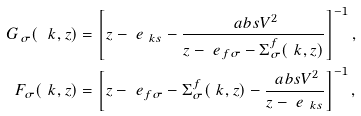Convert formula to latex. <formula><loc_0><loc_0><loc_500><loc_500>G _ { \sigma } ( \ k , z ) & = \left [ z - \ e _ { \ k s } - \frac { \ a b s { V } ^ { 2 } } { z - \ e _ { f \sigma } - \Sigma ^ { f } _ { \sigma } ( \ k , z ) } \right ] ^ { - 1 } , \\ F _ { \sigma } ( \ k , z ) & = \left [ z - \ e _ { f \sigma } - \Sigma ^ { f } _ { \sigma } ( \ k , z ) - \frac { \ a b s { V } ^ { 2 } } { z - \ e _ { \ k s } } \right ] ^ { - 1 } ,</formula> 